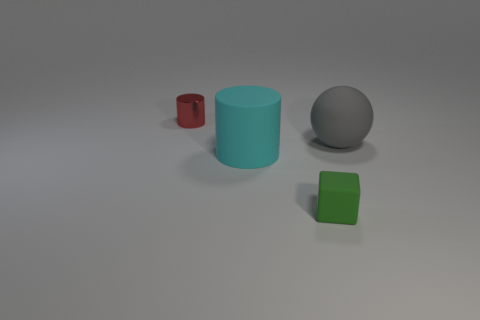Which object in the image appears to be the largest? The cyan-colored cylinder in the middle seems to be the largest object in this image. And which one seems the smallest? The small green cube in the foreground appears to be the smallest object here. 